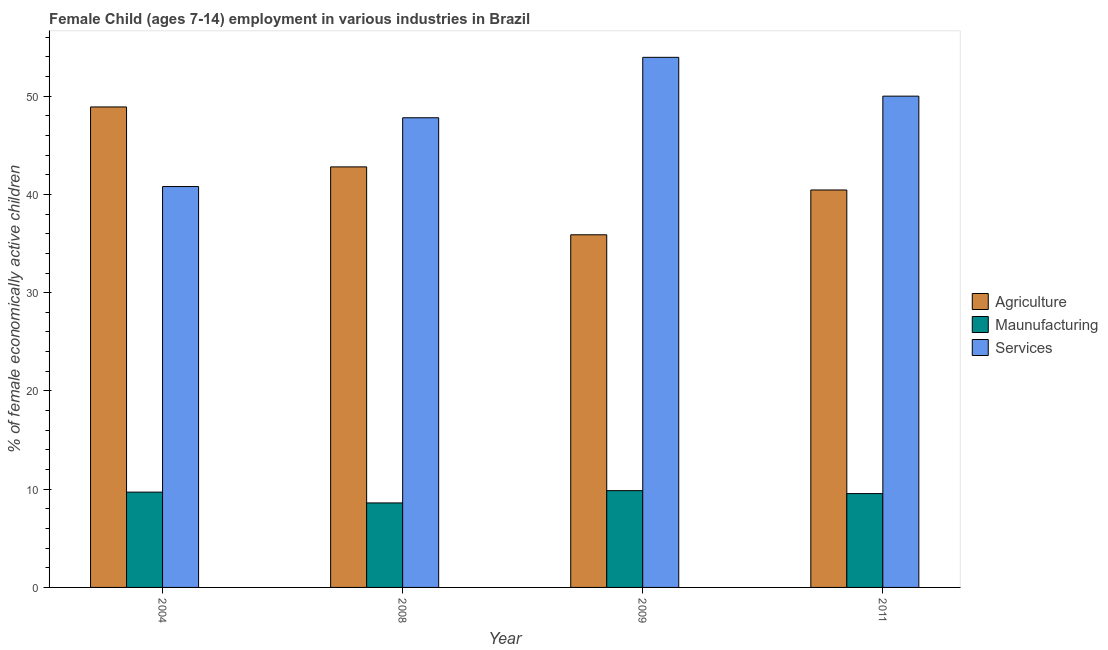How many different coloured bars are there?
Offer a very short reply. 3. How many groups of bars are there?
Provide a short and direct response. 4. Are the number of bars on each tick of the X-axis equal?
Provide a short and direct response. Yes. What is the label of the 4th group of bars from the left?
Make the answer very short. 2011. What is the percentage of economically active children in agriculture in 2008?
Your response must be concise. 42.8. Across all years, what is the maximum percentage of economically active children in manufacturing?
Offer a very short reply. 9.85. Across all years, what is the minimum percentage of economically active children in manufacturing?
Provide a succinct answer. 8.6. In which year was the percentage of economically active children in services minimum?
Your answer should be very brief. 2004. What is the total percentage of economically active children in agriculture in the graph?
Provide a succinct answer. 168.04. What is the difference between the percentage of economically active children in agriculture in 2008 and that in 2009?
Your response must be concise. 6.91. What is the difference between the percentage of economically active children in agriculture in 2004 and the percentage of economically active children in services in 2009?
Your answer should be very brief. 13.01. What is the average percentage of economically active children in agriculture per year?
Offer a terse response. 42.01. What is the ratio of the percentage of economically active children in agriculture in 2004 to that in 2011?
Offer a very short reply. 1.21. Is the percentage of economically active children in services in 2004 less than that in 2009?
Your response must be concise. Yes. Is the difference between the percentage of economically active children in services in 2004 and 2008 greater than the difference between the percentage of economically active children in agriculture in 2004 and 2008?
Offer a terse response. No. What is the difference between the highest and the second highest percentage of economically active children in manufacturing?
Ensure brevity in your answer.  0.15. What is the difference between the highest and the lowest percentage of economically active children in agriculture?
Your answer should be very brief. 13.01. What does the 1st bar from the left in 2011 represents?
Your response must be concise. Agriculture. What does the 2nd bar from the right in 2008 represents?
Offer a terse response. Maunufacturing. Is it the case that in every year, the sum of the percentage of economically active children in agriculture and percentage of economically active children in manufacturing is greater than the percentage of economically active children in services?
Provide a short and direct response. No. How many bars are there?
Keep it short and to the point. 12. Are all the bars in the graph horizontal?
Keep it short and to the point. No. Are the values on the major ticks of Y-axis written in scientific E-notation?
Offer a terse response. No. Does the graph contain any zero values?
Make the answer very short. No. What is the title of the graph?
Your response must be concise. Female Child (ages 7-14) employment in various industries in Brazil. Does "Ores and metals" appear as one of the legend labels in the graph?
Provide a short and direct response. No. What is the label or title of the Y-axis?
Your answer should be compact. % of female economically active children. What is the % of female economically active children of Agriculture in 2004?
Your answer should be compact. 48.9. What is the % of female economically active children of Services in 2004?
Offer a very short reply. 40.8. What is the % of female economically active children in Agriculture in 2008?
Ensure brevity in your answer.  42.8. What is the % of female economically active children of Services in 2008?
Ensure brevity in your answer.  47.8. What is the % of female economically active children of Agriculture in 2009?
Make the answer very short. 35.89. What is the % of female economically active children of Maunufacturing in 2009?
Make the answer very short. 9.85. What is the % of female economically active children of Services in 2009?
Offer a very short reply. 53.95. What is the % of female economically active children in Agriculture in 2011?
Offer a terse response. 40.45. What is the % of female economically active children in Maunufacturing in 2011?
Offer a very short reply. 9.55. What is the % of female economically active children of Services in 2011?
Ensure brevity in your answer.  50. Across all years, what is the maximum % of female economically active children of Agriculture?
Offer a terse response. 48.9. Across all years, what is the maximum % of female economically active children of Maunufacturing?
Your answer should be compact. 9.85. Across all years, what is the maximum % of female economically active children in Services?
Ensure brevity in your answer.  53.95. Across all years, what is the minimum % of female economically active children of Agriculture?
Keep it short and to the point. 35.89. Across all years, what is the minimum % of female economically active children in Services?
Your answer should be compact. 40.8. What is the total % of female economically active children of Agriculture in the graph?
Ensure brevity in your answer.  168.04. What is the total % of female economically active children in Maunufacturing in the graph?
Provide a succinct answer. 37.7. What is the total % of female economically active children in Services in the graph?
Make the answer very short. 192.55. What is the difference between the % of female economically active children of Services in 2004 and that in 2008?
Your answer should be very brief. -7. What is the difference between the % of female economically active children of Agriculture in 2004 and that in 2009?
Make the answer very short. 13.01. What is the difference between the % of female economically active children in Services in 2004 and that in 2009?
Make the answer very short. -13.15. What is the difference between the % of female economically active children in Agriculture in 2004 and that in 2011?
Provide a short and direct response. 8.45. What is the difference between the % of female economically active children in Agriculture in 2008 and that in 2009?
Your answer should be very brief. 6.91. What is the difference between the % of female economically active children of Maunufacturing in 2008 and that in 2009?
Give a very brief answer. -1.25. What is the difference between the % of female economically active children in Services in 2008 and that in 2009?
Give a very brief answer. -6.15. What is the difference between the % of female economically active children of Agriculture in 2008 and that in 2011?
Ensure brevity in your answer.  2.35. What is the difference between the % of female economically active children in Maunufacturing in 2008 and that in 2011?
Your answer should be compact. -0.95. What is the difference between the % of female economically active children of Services in 2008 and that in 2011?
Your answer should be compact. -2.2. What is the difference between the % of female economically active children of Agriculture in 2009 and that in 2011?
Your answer should be compact. -4.56. What is the difference between the % of female economically active children in Maunufacturing in 2009 and that in 2011?
Keep it short and to the point. 0.3. What is the difference between the % of female economically active children of Services in 2009 and that in 2011?
Your response must be concise. 3.95. What is the difference between the % of female economically active children of Agriculture in 2004 and the % of female economically active children of Maunufacturing in 2008?
Your response must be concise. 40.3. What is the difference between the % of female economically active children in Agriculture in 2004 and the % of female economically active children in Services in 2008?
Keep it short and to the point. 1.1. What is the difference between the % of female economically active children of Maunufacturing in 2004 and the % of female economically active children of Services in 2008?
Make the answer very short. -38.1. What is the difference between the % of female economically active children of Agriculture in 2004 and the % of female economically active children of Maunufacturing in 2009?
Give a very brief answer. 39.05. What is the difference between the % of female economically active children in Agriculture in 2004 and the % of female economically active children in Services in 2009?
Your answer should be very brief. -5.05. What is the difference between the % of female economically active children of Maunufacturing in 2004 and the % of female economically active children of Services in 2009?
Ensure brevity in your answer.  -44.25. What is the difference between the % of female economically active children of Agriculture in 2004 and the % of female economically active children of Maunufacturing in 2011?
Give a very brief answer. 39.35. What is the difference between the % of female economically active children in Maunufacturing in 2004 and the % of female economically active children in Services in 2011?
Offer a terse response. -40.3. What is the difference between the % of female economically active children of Agriculture in 2008 and the % of female economically active children of Maunufacturing in 2009?
Your answer should be compact. 32.95. What is the difference between the % of female economically active children of Agriculture in 2008 and the % of female economically active children of Services in 2009?
Give a very brief answer. -11.15. What is the difference between the % of female economically active children of Maunufacturing in 2008 and the % of female economically active children of Services in 2009?
Keep it short and to the point. -45.35. What is the difference between the % of female economically active children of Agriculture in 2008 and the % of female economically active children of Maunufacturing in 2011?
Make the answer very short. 33.25. What is the difference between the % of female economically active children of Agriculture in 2008 and the % of female economically active children of Services in 2011?
Make the answer very short. -7.2. What is the difference between the % of female economically active children in Maunufacturing in 2008 and the % of female economically active children in Services in 2011?
Make the answer very short. -41.4. What is the difference between the % of female economically active children of Agriculture in 2009 and the % of female economically active children of Maunufacturing in 2011?
Ensure brevity in your answer.  26.34. What is the difference between the % of female economically active children of Agriculture in 2009 and the % of female economically active children of Services in 2011?
Your answer should be very brief. -14.11. What is the difference between the % of female economically active children of Maunufacturing in 2009 and the % of female economically active children of Services in 2011?
Offer a very short reply. -40.15. What is the average % of female economically active children in Agriculture per year?
Provide a succinct answer. 42.01. What is the average % of female economically active children of Maunufacturing per year?
Offer a terse response. 9.43. What is the average % of female economically active children in Services per year?
Provide a short and direct response. 48.14. In the year 2004, what is the difference between the % of female economically active children in Agriculture and % of female economically active children in Maunufacturing?
Keep it short and to the point. 39.2. In the year 2004, what is the difference between the % of female economically active children of Agriculture and % of female economically active children of Services?
Ensure brevity in your answer.  8.1. In the year 2004, what is the difference between the % of female economically active children in Maunufacturing and % of female economically active children in Services?
Offer a very short reply. -31.1. In the year 2008, what is the difference between the % of female economically active children of Agriculture and % of female economically active children of Maunufacturing?
Provide a short and direct response. 34.2. In the year 2008, what is the difference between the % of female economically active children of Agriculture and % of female economically active children of Services?
Keep it short and to the point. -5. In the year 2008, what is the difference between the % of female economically active children of Maunufacturing and % of female economically active children of Services?
Your response must be concise. -39.2. In the year 2009, what is the difference between the % of female economically active children in Agriculture and % of female economically active children in Maunufacturing?
Your response must be concise. 26.04. In the year 2009, what is the difference between the % of female economically active children in Agriculture and % of female economically active children in Services?
Give a very brief answer. -18.06. In the year 2009, what is the difference between the % of female economically active children in Maunufacturing and % of female economically active children in Services?
Your response must be concise. -44.1. In the year 2011, what is the difference between the % of female economically active children of Agriculture and % of female economically active children of Maunufacturing?
Offer a terse response. 30.9. In the year 2011, what is the difference between the % of female economically active children of Agriculture and % of female economically active children of Services?
Keep it short and to the point. -9.55. In the year 2011, what is the difference between the % of female economically active children in Maunufacturing and % of female economically active children in Services?
Provide a short and direct response. -40.45. What is the ratio of the % of female economically active children in Agriculture in 2004 to that in 2008?
Provide a succinct answer. 1.14. What is the ratio of the % of female economically active children of Maunufacturing in 2004 to that in 2008?
Give a very brief answer. 1.13. What is the ratio of the % of female economically active children in Services in 2004 to that in 2008?
Provide a short and direct response. 0.85. What is the ratio of the % of female economically active children of Agriculture in 2004 to that in 2009?
Your answer should be very brief. 1.36. What is the ratio of the % of female economically active children of Maunufacturing in 2004 to that in 2009?
Give a very brief answer. 0.98. What is the ratio of the % of female economically active children of Services in 2004 to that in 2009?
Your answer should be compact. 0.76. What is the ratio of the % of female economically active children of Agriculture in 2004 to that in 2011?
Your response must be concise. 1.21. What is the ratio of the % of female economically active children in Maunufacturing in 2004 to that in 2011?
Your answer should be very brief. 1.02. What is the ratio of the % of female economically active children of Services in 2004 to that in 2011?
Make the answer very short. 0.82. What is the ratio of the % of female economically active children in Agriculture in 2008 to that in 2009?
Offer a terse response. 1.19. What is the ratio of the % of female economically active children in Maunufacturing in 2008 to that in 2009?
Provide a short and direct response. 0.87. What is the ratio of the % of female economically active children in Services in 2008 to that in 2009?
Your answer should be very brief. 0.89. What is the ratio of the % of female economically active children in Agriculture in 2008 to that in 2011?
Keep it short and to the point. 1.06. What is the ratio of the % of female economically active children in Maunufacturing in 2008 to that in 2011?
Your answer should be very brief. 0.9. What is the ratio of the % of female economically active children of Services in 2008 to that in 2011?
Offer a terse response. 0.96. What is the ratio of the % of female economically active children in Agriculture in 2009 to that in 2011?
Provide a succinct answer. 0.89. What is the ratio of the % of female economically active children in Maunufacturing in 2009 to that in 2011?
Make the answer very short. 1.03. What is the ratio of the % of female economically active children of Services in 2009 to that in 2011?
Ensure brevity in your answer.  1.08. What is the difference between the highest and the second highest % of female economically active children in Maunufacturing?
Provide a short and direct response. 0.15. What is the difference between the highest and the second highest % of female economically active children in Services?
Offer a very short reply. 3.95. What is the difference between the highest and the lowest % of female economically active children in Agriculture?
Provide a short and direct response. 13.01. What is the difference between the highest and the lowest % of female economically active children in Services?
Your response must be concise. 13.15. 